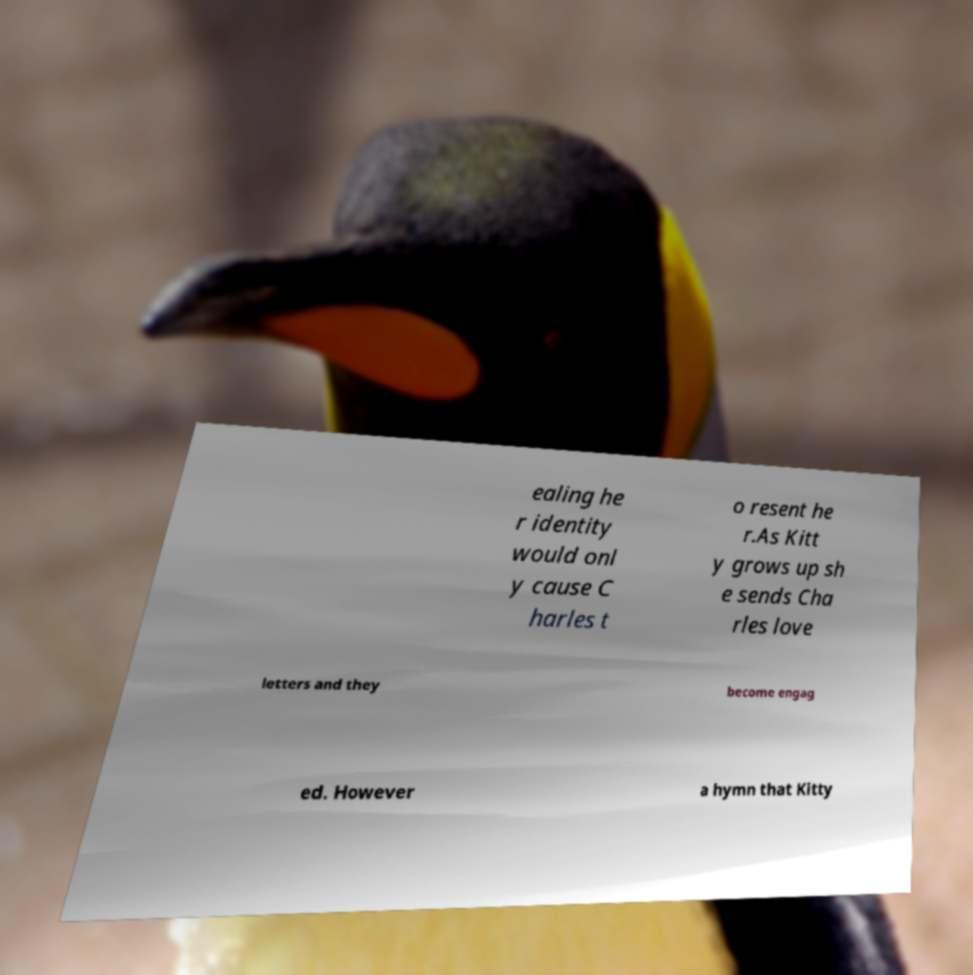For documentation purposes, I need the text within this image transcribed. Could you provide that? ealing he r identity would onl y cause C harles t o resent he r.As Kitt y grows up sh e sends Cha rles love letters and they become engag ed. However a hymn that Kitty 